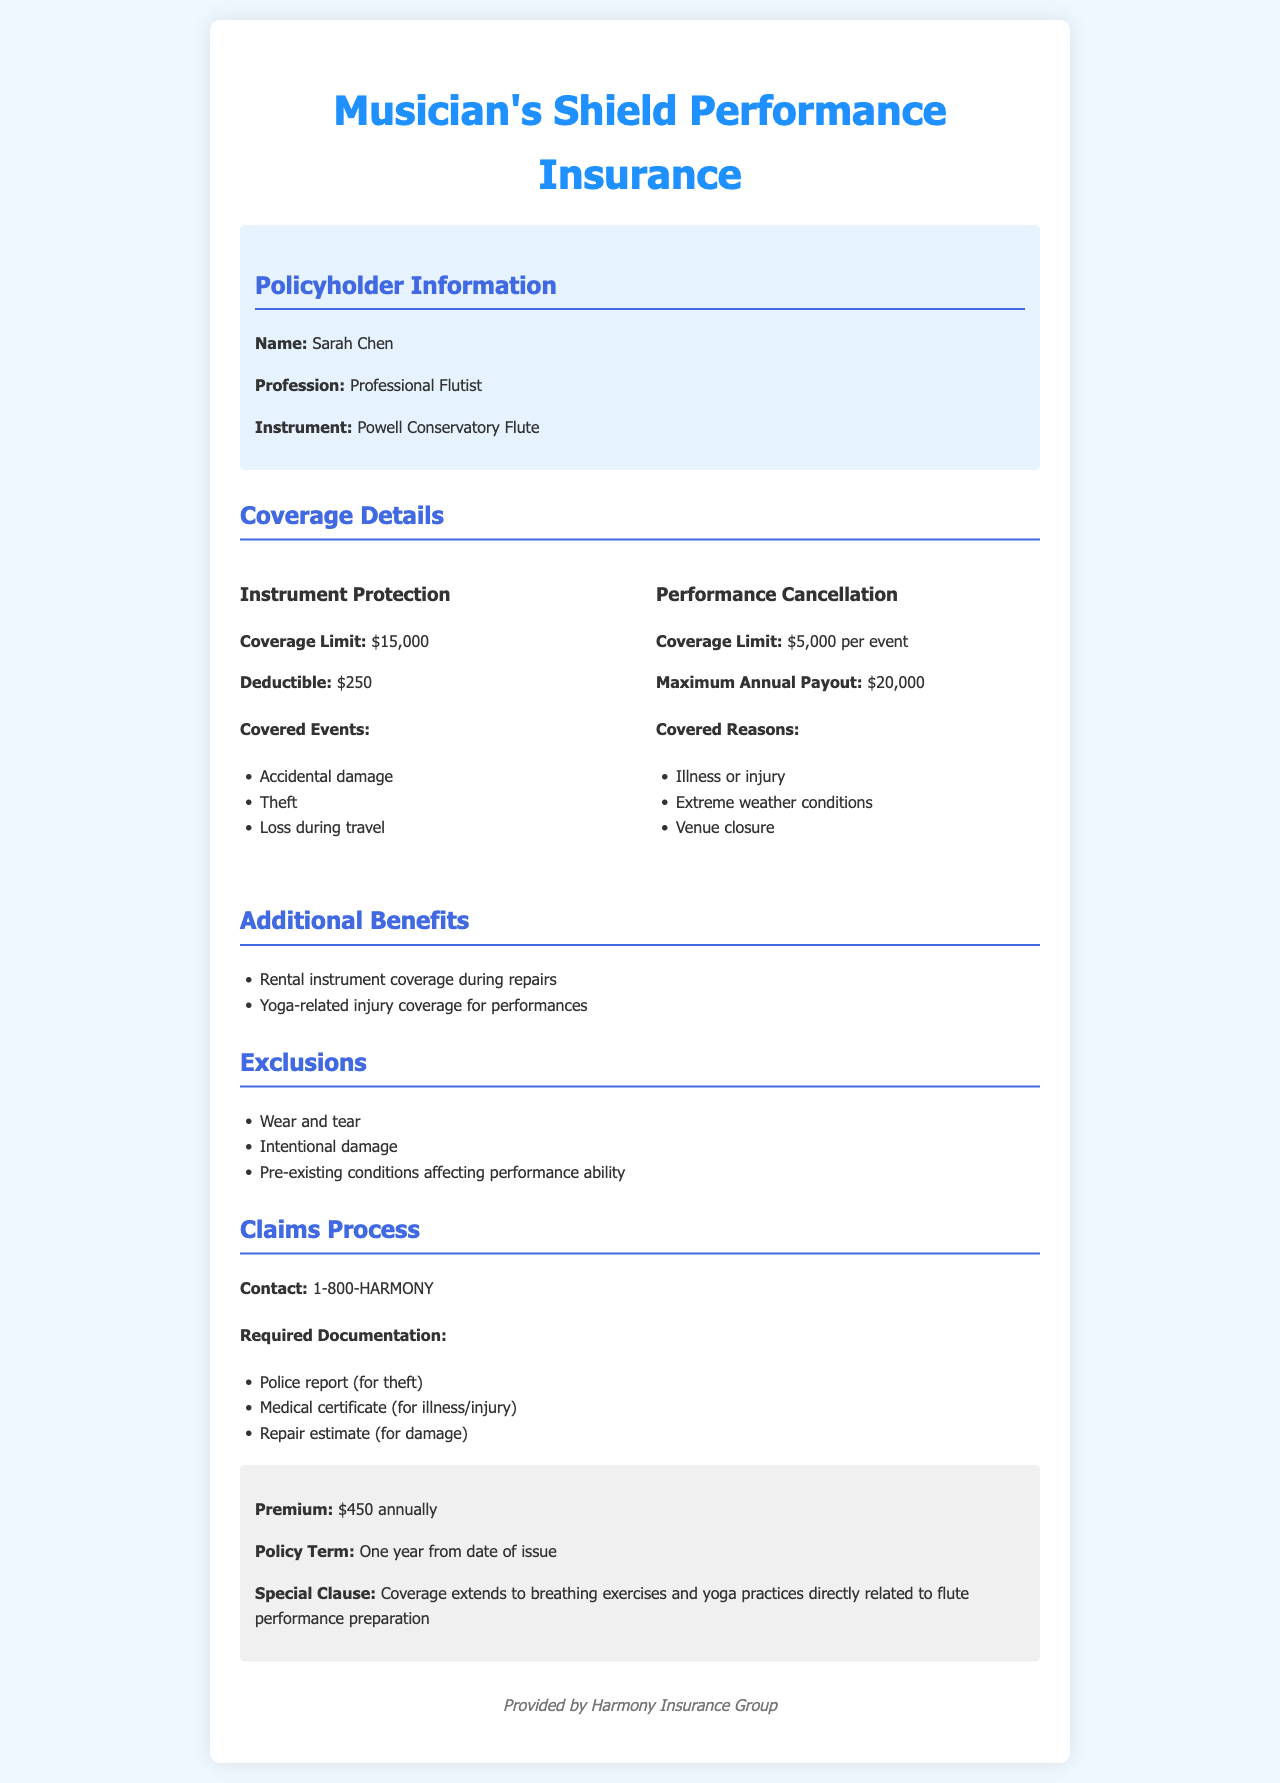What is the name of the policyholder? The policyholder's name is specifically mentioned in the document.
Answer: Sarah Chen What is the instrument covered by the insurance? The type of instrument that is insured is stated in the document.
Answer: Powell Conservatory Flute What is the coverage limit for instrument protection? The document specifies a limit for instrument protection coverage.
Answer: $15,000 What is the annual premium for the insurance policy? The cost of the insurance policy is clearly listed in the document.
Answer: $450 What is the maximum annual payout for performance cancellations? The document provides a maximum payout that is defined for performance cancellations.
Answer: $20,000 What is one of the covered reasons for performance cancellation? The document lists reasons that would be covered for performance cancellations.
Answer: Illness or injury Is there coverage for yoga-related injuries related to performance? The document mentions specific coverage related to yoga practices.
Answer: Yes What type of event is excluded from the coverage? The document specifies certain exclusions from the insurance policy.
Answer: Wear and tear What is the contact number for claims? The document provides a specific contact number for the claims process.
Answer: 1-800-HARMONY 